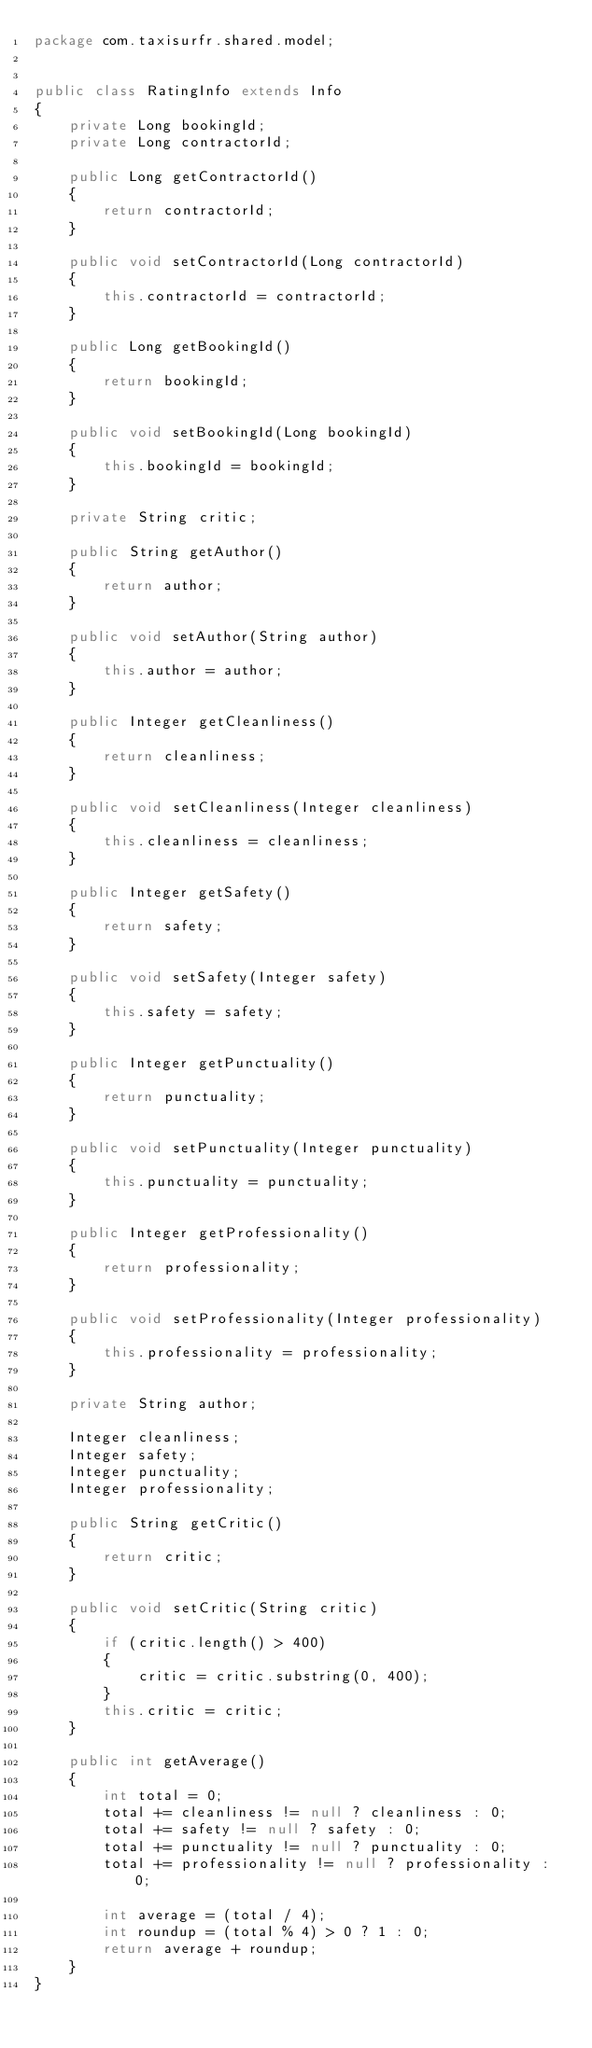Convert code to text. <code><loc_0><loc_0><loc_500><loc_500><_Java_>package com.taxisurfr.shared.model;


public class RatingInfo extends Info
{
    private Long bookingId;
    private Long contractorId;

    public Long getContractorId()
    {
        return contractorId;
    }

    public void setContractorId(Long contractorId)
    {
        this.contractorId = contractorId;
    }

    public Long getBookingId()
    {
        return bookingId;
    }

    public void setBookingId(Long bookingId)
    {
        this.bookingId = bookingId;
    }

    private String critic;

    public String getAuthor()
    {
        return author;
    }

    public void setAuthor(String author)
    {
        this.author = author;
    }

    public Integer getCleanliness()
    {
        return cleanliness;
    }

    public void setCleanliness(Integer cleanliness)
    {
        this.cleanliness = cleanliness;
    }

    public Integer getSafety()
    {
        return safety;
    }

    public void setSafety(Integer safety)
    {
        this.safety = safety;
    }

    public Integer getPunctuality()
    {
        return punctuality;
    }

    public void setPunctuality(Integer punctuality)
    {
        this.punctuality = punctuality;
    }

    public Integer getProfessionality()
    {
        return professionality;
    }

    public void setProfessionality(Integer professionality)
    {
        this.professionality = professionality;
    }

    private String author;

    Integer cleanliness;
    Integer safety;
    Integer punctuality;
    Integer professionality;

    public String getCritic()
    {
        return critic;
    }

    public void setCritic(String critic)
    {
        if (critic.length() > 400)
        {
            critic = critic.substring(0, 400);
        }
        this.critic = critic;
    }

    public int getAverage()
    {
        int total = 0;
        total += cleanliness != null ? cleanliness : 0;
        total += safety != null ? safety : 0;
        total += punctuality != null ? punctuality : 0;
        total += professionality != null ? professionality : 0;

        int average = (total / 4);
        int roundup = (total % 4) > 0 ? 1 : 0;
        return average + roundup;
    }
}
</code> 